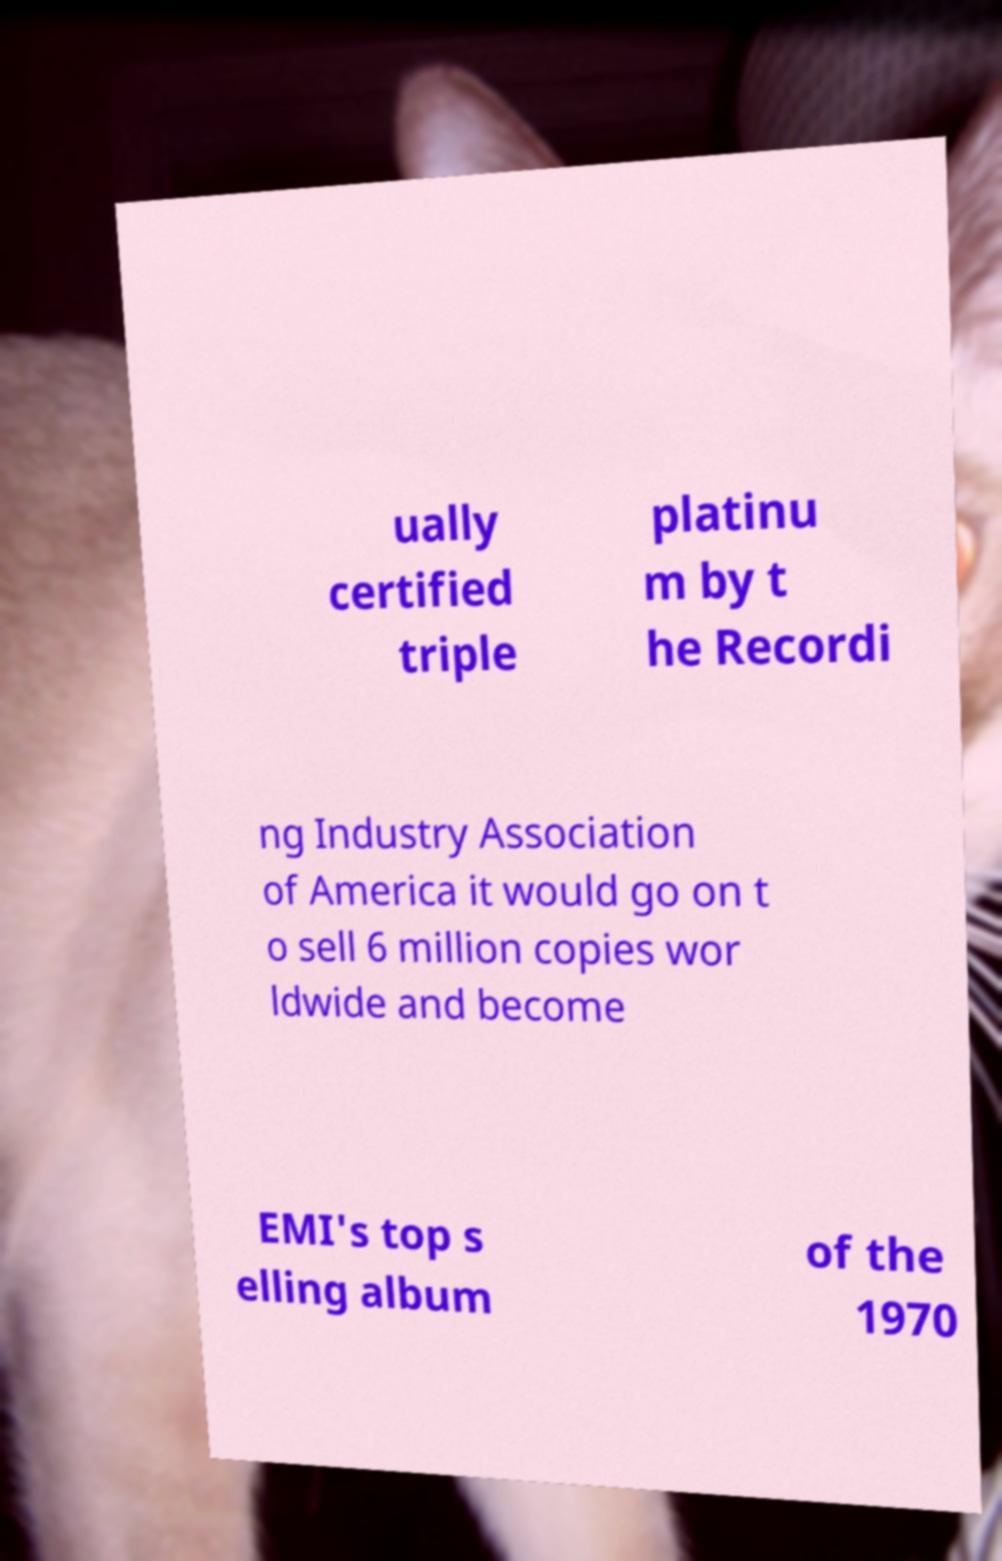Can you accurately transcribe the text from the provided image for me? ually certified triple platinu m by t he Recordi ng Industry Association of America it would go on t o sell 6 million copies wor ldwide and become EMI's top s elling album of the 1970 